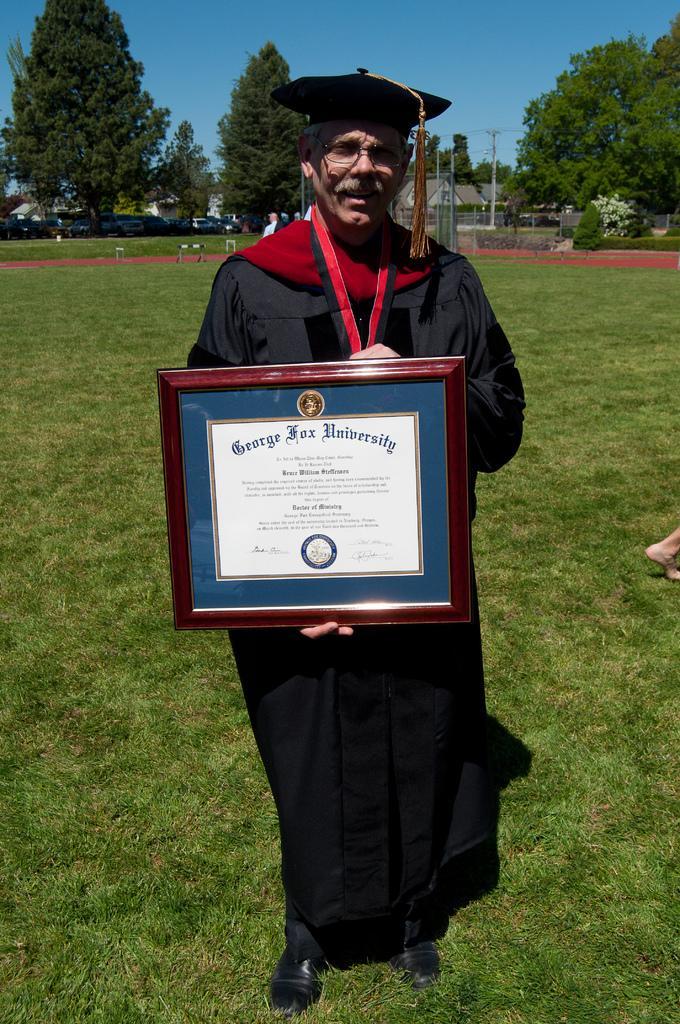How would you summarize this image in a sentence or two? In the center of the image a man is standing and holding a diploma. In the background of the image we can see a trees, poles, houses, cars are present. At the bottom of the image grass is there. At the top of the image sky is present. 